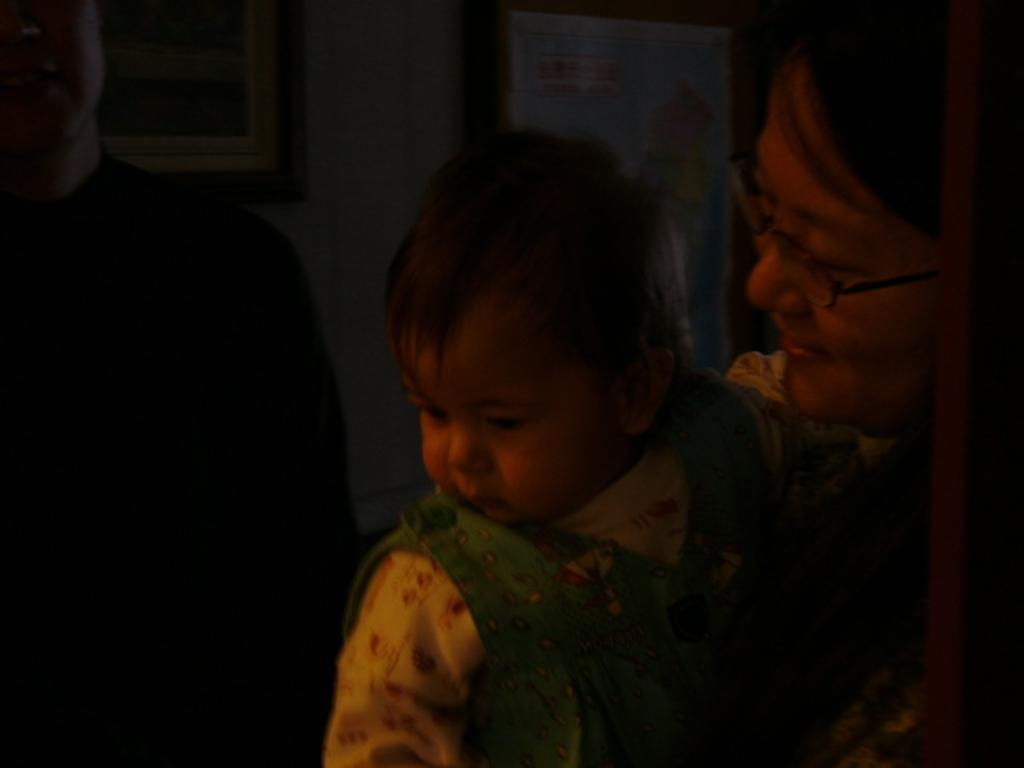What is happening on the right side of the image? There is a person holding a baby on the right side of the image. What can be seen on the left side of the image? There is a man with a black dress on the left side of the image. How is the man described in the image? The man is stunning. What is visible in the background of the image? There is a wall with frames in the background of the image. What type of story is the yam telling in the image? There is no yam present in the image, and therefore no story can be told by a yam. How does the person holding the baby burn calories in the image? There is no indication in the image that the person holding the baby is burning calories, and the concept of burning calories is not relevant to the image. 